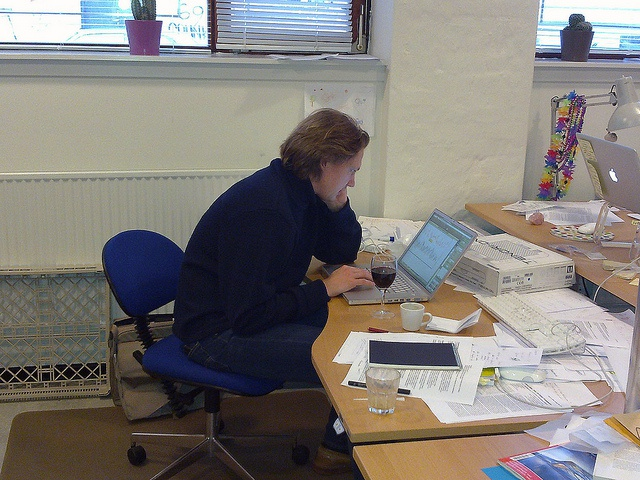Describe the objects in this image and their specific colors. I can see people in white, black, and gray tones, chair in white, navy, black, gray, and darkgray tones, laptop in white, gray, and darkgray tones, backpack in white, black, and gray tones, and laptop in white, gray, and darkgray tones in this image. 